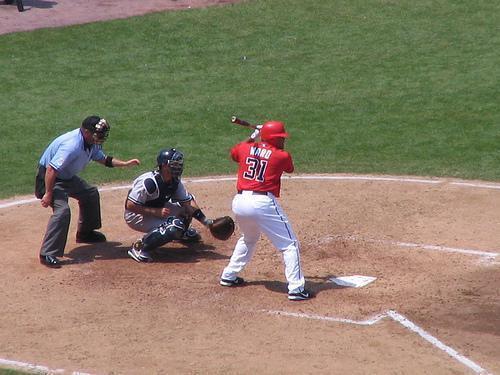How many people are visible in the picture?
Give a very brief answer. 3. 